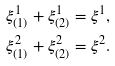Convert formula to latex. <formula><loc_0><loc_0><loc_500><loc_500>\xi _ { ( 1 ) } ^ { 1 } + \xi _ { ( 2 ) } ^ { 1 } & = \xi ^ { 1 } , \\ \xi _ { ( 1 ) } ^ { 2 } + \xi _ { ( 2 ) } ^ { 2 } & = \xi ^ { 2 } .</formula> 